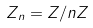<formula> <loc_0><loc_0><loc_500><loc_500>Z _ { n } = Z / n Z</formula> 